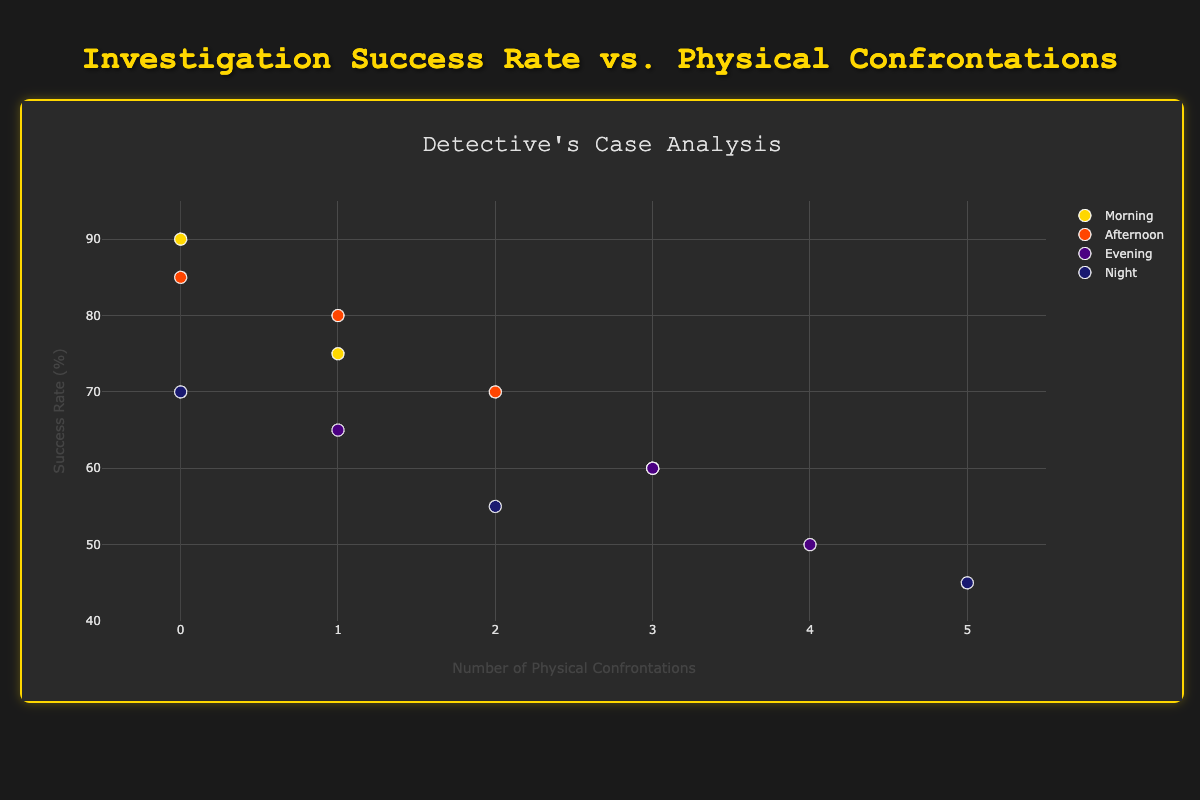How many data points are plotted for investigations done in the Morning? The scatter plot includes different time-of-day groupings represented by distinct colors. Counting the markers for the Morning category, there are 3 in total.
Answer: 3 Which time of day has the highest success rate? The scatter plot shows data points grouped by time of day along with their corresponding success rates. The highest success rate, which is 90%, occurs in the Morning.
Answer: Morning What is the range of physical confrontations observed in the Night time period? Observing the x-axis values for data points in the Night category, the physical confrontations range from 0 to 5.
Answer: 0 to 5 Compare the success rates for investigations with 0 physical confrontations: which time of day performed best? By checking the scatter plot for data points where physical confrontations = 0, we find three points at different times of day: Morning (90%), Afternoon (85%), and Night (70%). The highest success rate is in the Morning at 90%.
Answer: Morning During which time of day is the success rate most varied, and what is the range of success rates for that period? To determine the variability, we observe the spread of success rates for each time period. For the Evening, the success rates vary from 50% to 65%, the widest range among the time periods.
Answer: Evening, 50% to 65% What's the median success rate for investigations conducted in the Afternoon? The scatter plot shows three data points for Afternoon with success rates of 85%, 70%, and 80%. Arranged in order, the median value is the middle one, which is 80%.
Answer: 80% What is the relationship between the number of physical confrontations and the success rate for the Evening time period? Observing the scatter plot for Evening data points, as physical confrontations increase from 1 to 4, the success rate decreases from 65% to 50%.
Answer: Negative correlation Is there a case with 2 physical confrontations and what is its success rate and time of day? Checking the scatter plot, there are instances with 2 physical confrontations: "Kidnapping Case" in the Afternoon with a success rate of 70%, and "Arson Investigation" at Night with a success rate of 55%.
Answer: 70% in Afternoon, 55% at Night Which case has the lowest success rate, and how many physical confrontations did it involve? The scatter plot shows that the "Midnight Burglary" case during the Night has the lowest success rate at 45%. It involves 5 physical confrontations.
Answer: Midnight Burglary, 5 